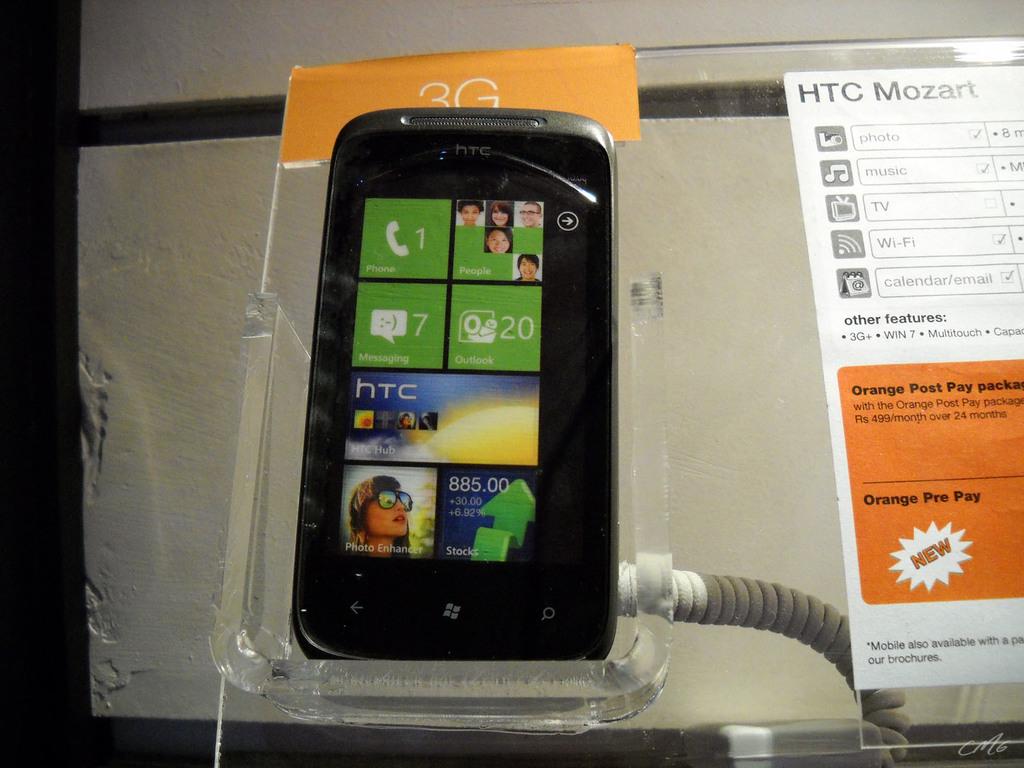How many messages are on the phone?
Make the answer very short. 7. What brand is this phone?
Your answer should be compact. Htc. 